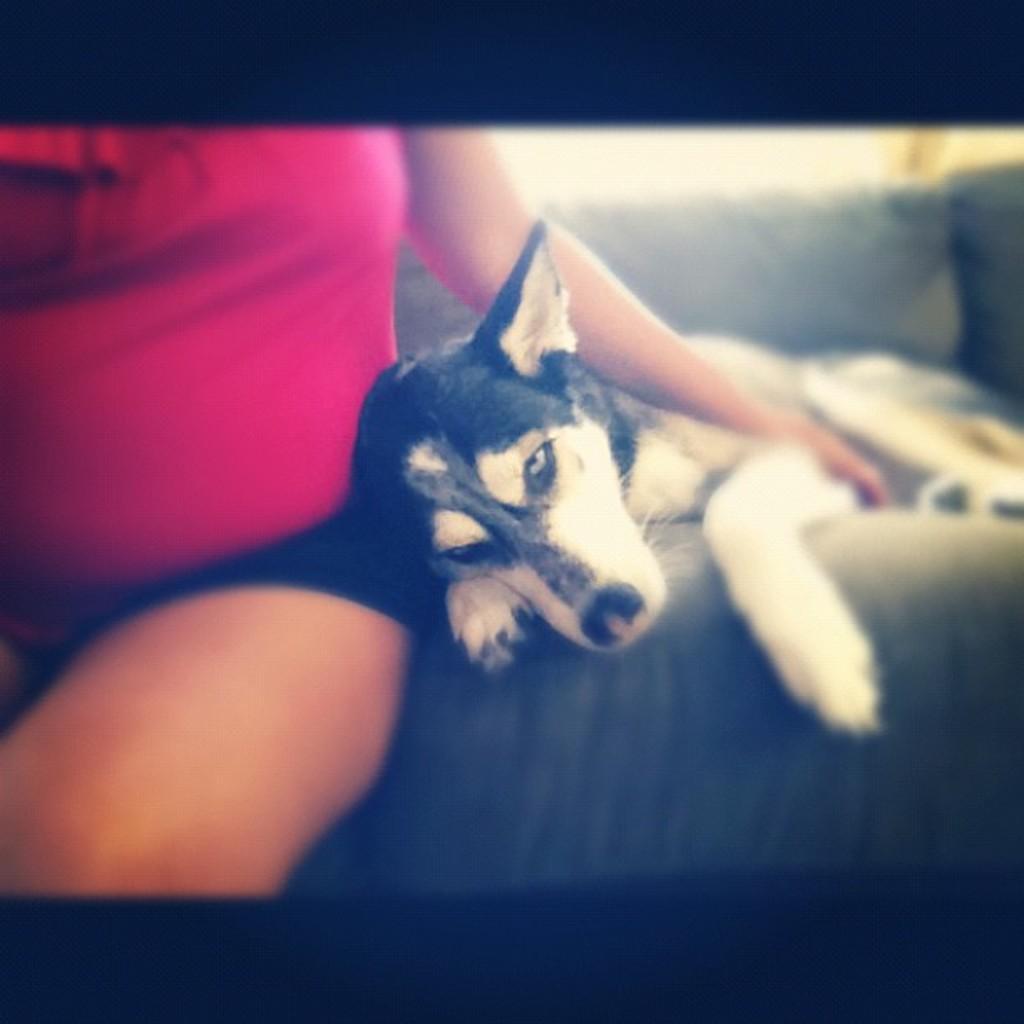Describe this image in one or two sentences. In this image I can see the person wearing the pink and black color dress and sitting on the couch. To the side I can see the dog which is in white and black color. And there is a black background. 